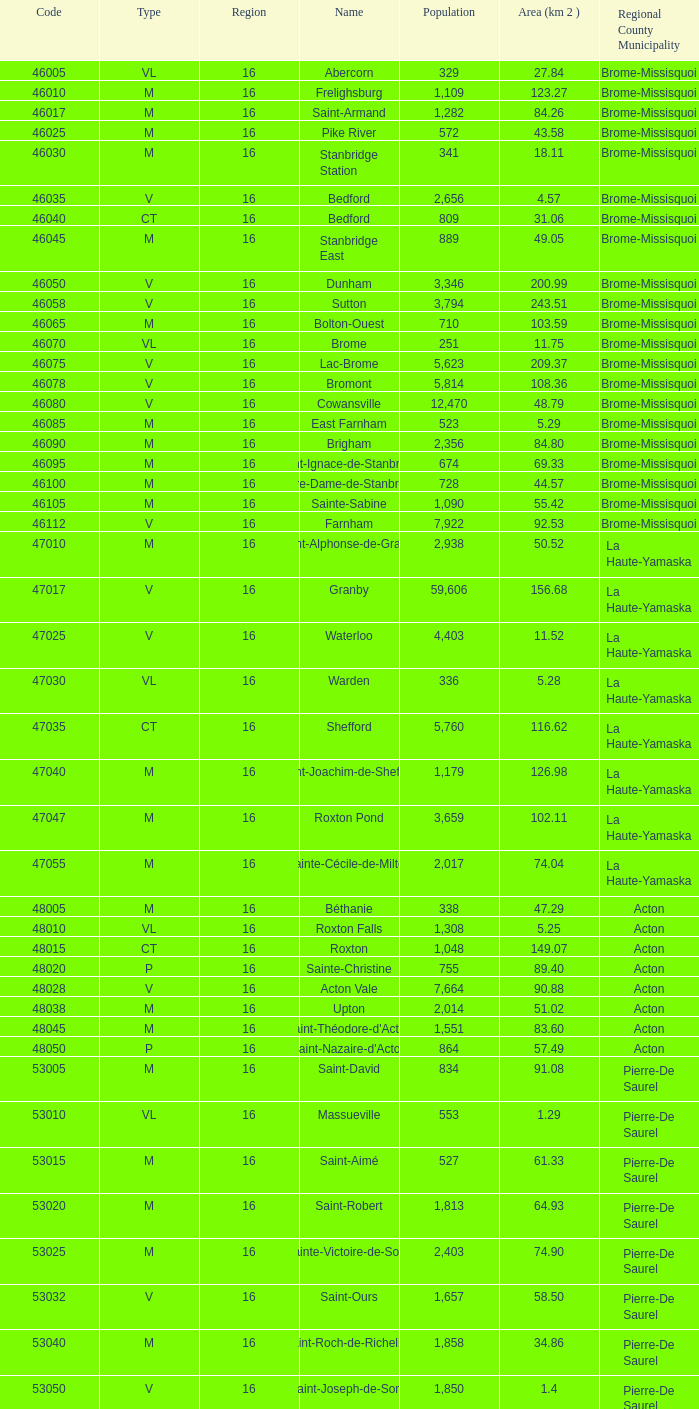What is the code for a Le Haut-Saint-Laurent municipality that has 16 or more regions? None. 